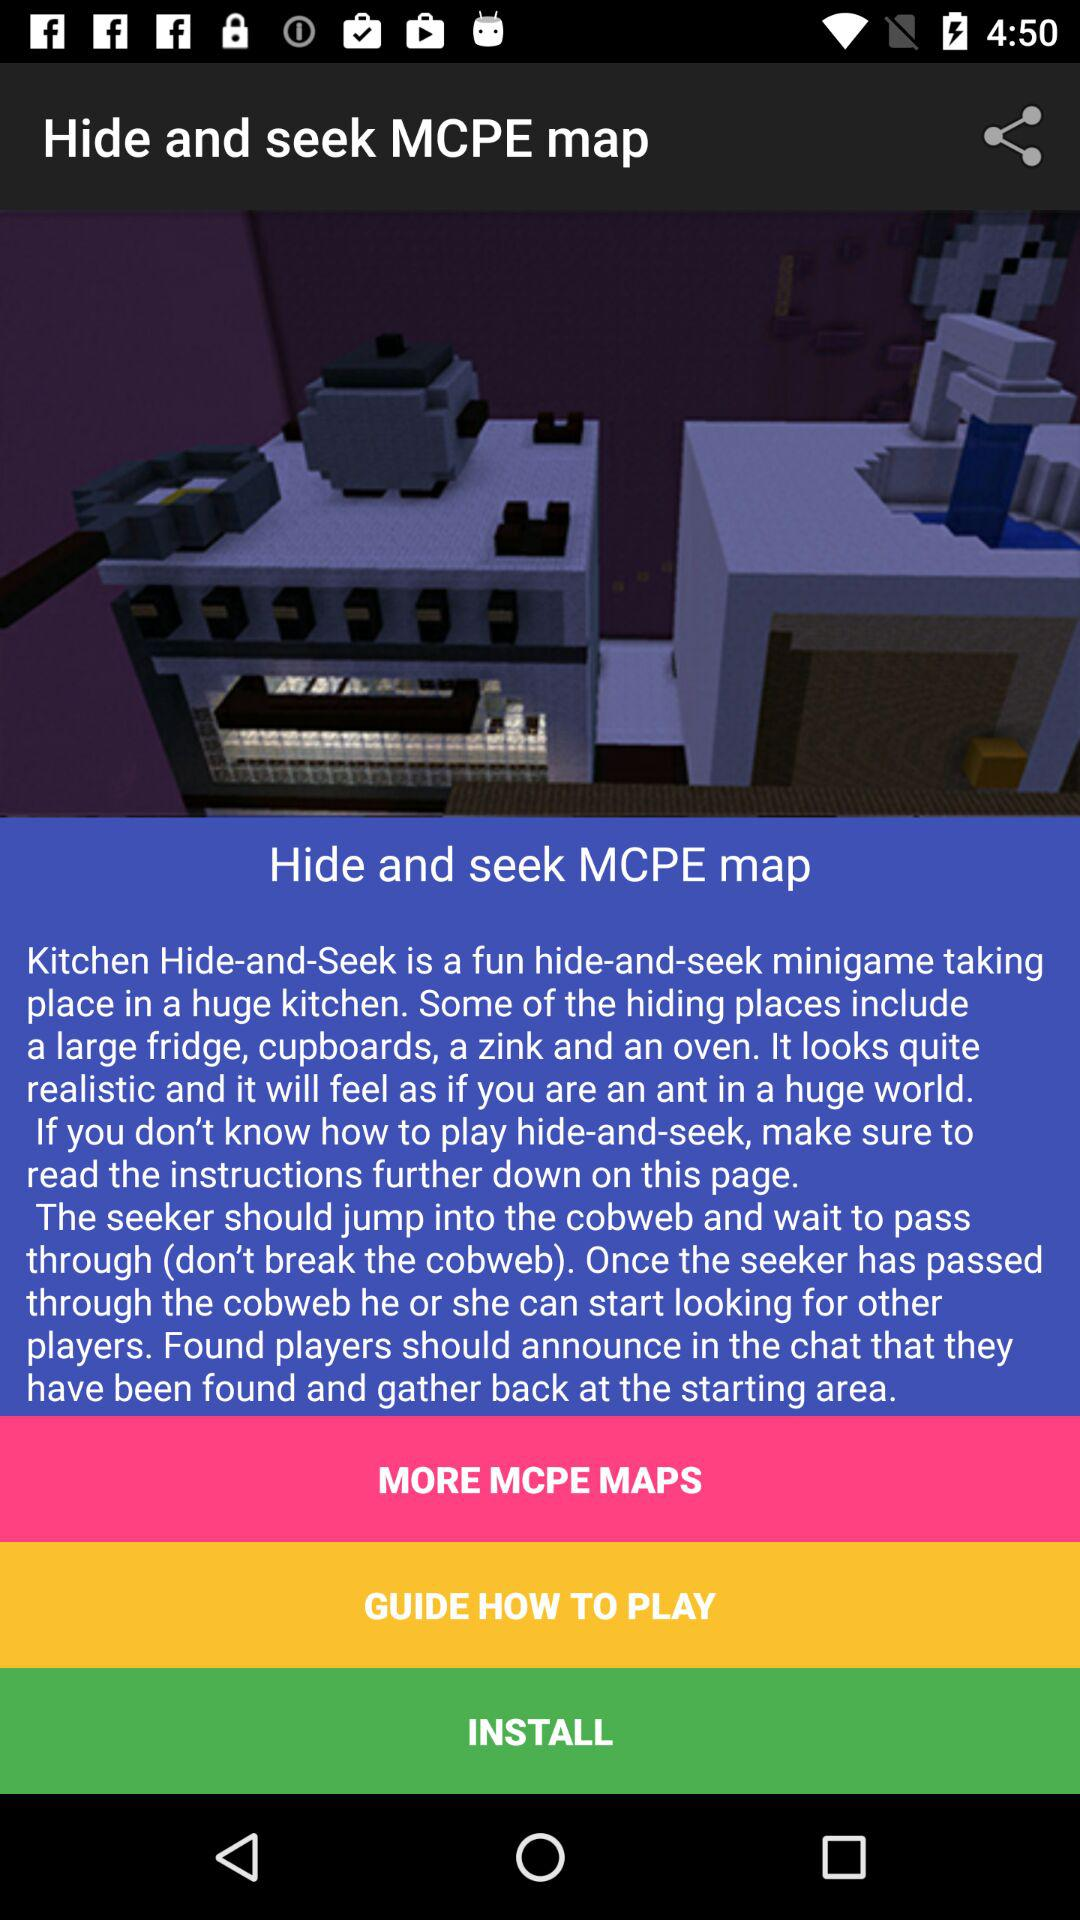Which maps are provided in "MORE MCPE MAPS"?
When the provided information is insufficient, respond with <no answer>. <no answer> 